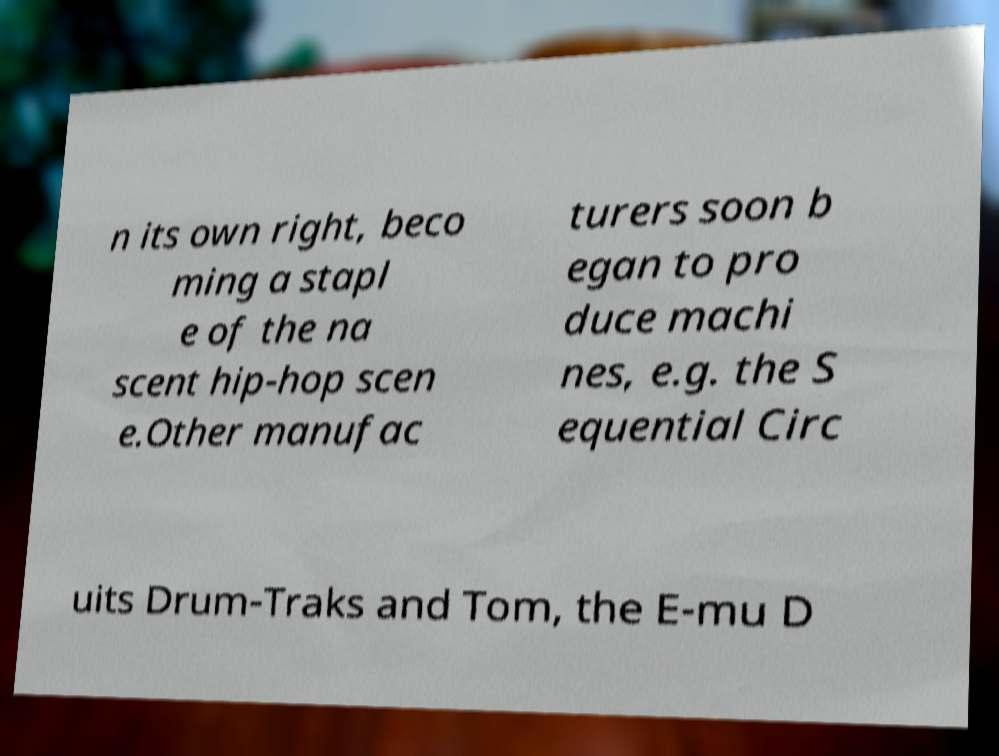Please read and relay the text visible in this image. What does it say? n its own right, beco ming a stapl e of the na scent hip-hop scen e.Other manufac turers soon b egan to pro duce machi nes, e.g. the S equential Circ uits Drum-Traks and Tom, the E-mu D 